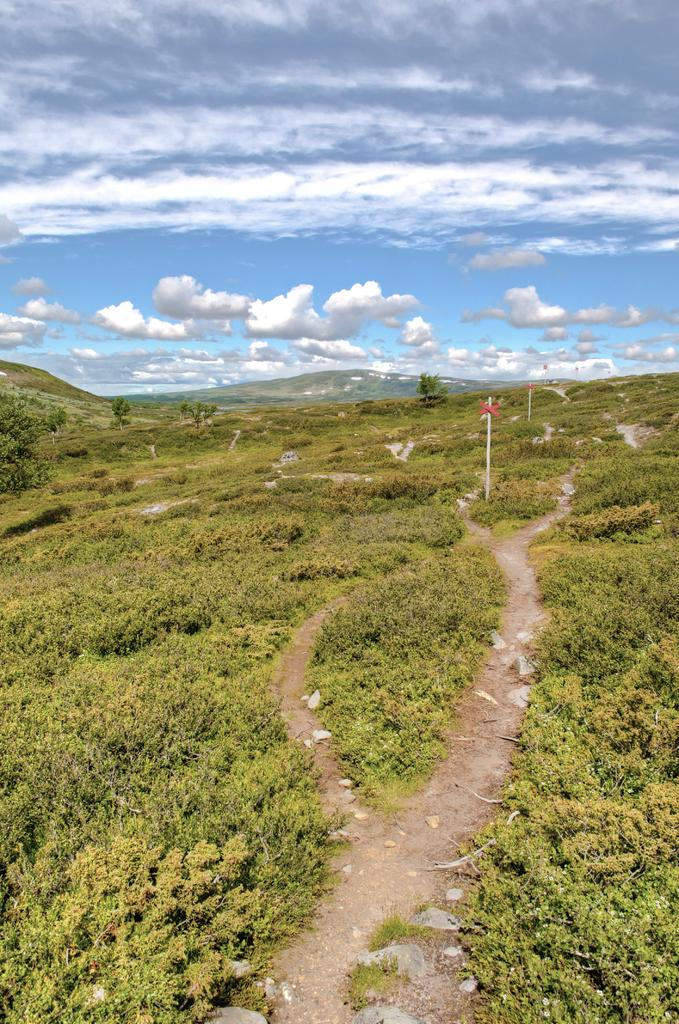What type of vegetation can be seen in the image? There are plants and trees in the image. What structures are present in the image? There are poles in the image. What type of landscape feature is visible in the image? There are hills in the image. What is visible in the background of the image? The sky is visible in the background of the image. How many geese are flying over the hills in the image? There are no geese present in the image; it only features plants, trees, poles, hills, and the sky. Can you see a skate being used on the hills in the image? There is no skate present in the image; it only features plants, trees, poles, hills, and the sky. 